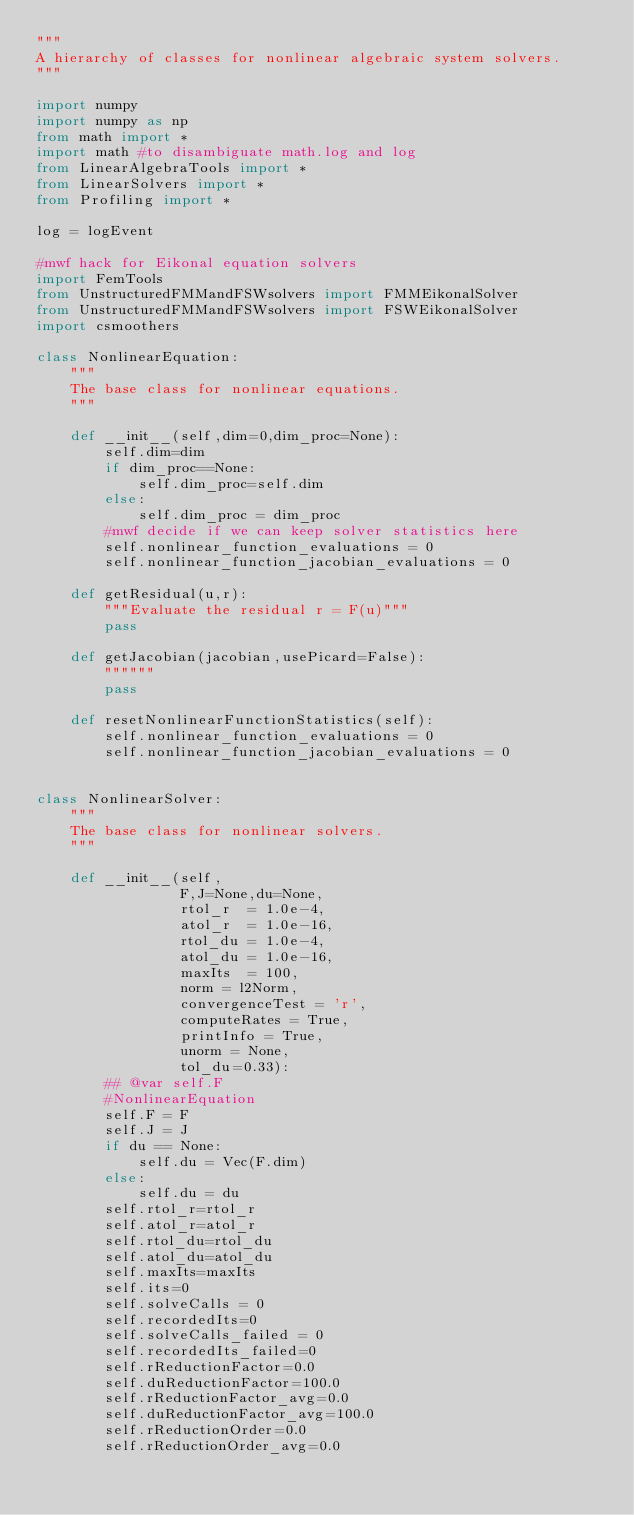Convert code to text. <code><loc_0><loc_0><loc_500><loc_500><_Python_>"""
A hierarchy of classes for nonlinear algebraic system solvers.
"""

import numpy
import numpy as np
from math import *
import math #to disambiguate math.log and log
from LinearAlgebraTools import *
from LinearSolvers import *
from Profiling import *

log = logEvent

#mwf hack for Eikonal equation solvers
import FemTools
from UnstructuredFMMandFSWsolvers import FMMEikonalSolver
from UnstructuredFMMandFSWsolvers import FSWEikonalSolver
import csmoothers

class NonlinearEquation:
    """
    The base class for nonlinear equations.
    """

    def __init__(self,dim=0,dim_proc=None):
        self.dim=dim
        if dim_proc==None:
            self.dim_proc=self.dim
        else:
            self.dim_proc = dim_proc
        #mwf decide if we can keep solver statistics here
        self.nonlinear_function_evaluations = 0
        self.nonlinear_function_jacobian_evaluations = 0

    def getResidual(u,r):
        """Evaluate the residual r = F(u)"""
        pass

    def getJacobian(jacobian,usePicard=False):
        """"""
        pass

    def resetNonlinearFunctionStatistics(self):
        self.nonlinear_function_evaluations = 0
        self.nonlinear_function_jacobian_evaluations = 0


class NonlinearSolver:
    """
    The base class for nonlinear solvers.
    """

    def __init__(self,
                 F,J=None,du=None,
                 rtol_r  = 1.0e-4,
                 atol_r  = 1.0e-16,
                 rtol_du = 1.0e-4,
                 atol_du = 1.0e-16,
                 maxIts  = 100,
                 norm = l2Norm,
                 convergenceTest = 'r',
                 computeRates = True,
                 printInfo = True,
                 unorm = None,
                 tol_du=0.33):
        ## @var self.F
        #NonlinearEquation
        self.F = F
        self.J = J
        if du == None:
            self.du = Vec(F.dim)
        else:
            self.du = du
        self.rtol_r=rtol_r
        self.atol_r=atol_r
        self.rtol_du=rtol_du
        self.atol_du=atol_du
        self.maxIts=maxIts
        self.its=0
        self.solveCalls = 0
        self.recordedIts=0
        self.solveCalls_failed = 0
        self.recordedIts_failed=0
        self.rReductionFactor=0.0
        self.duReductionFactor=100.0
        self.rReductionFactor_avg=0.0
        self.duReductionFactor_avg=100.0
        self.rReductionOrder=0.0
        self.rReductionOrder_avg=0.0</code> 